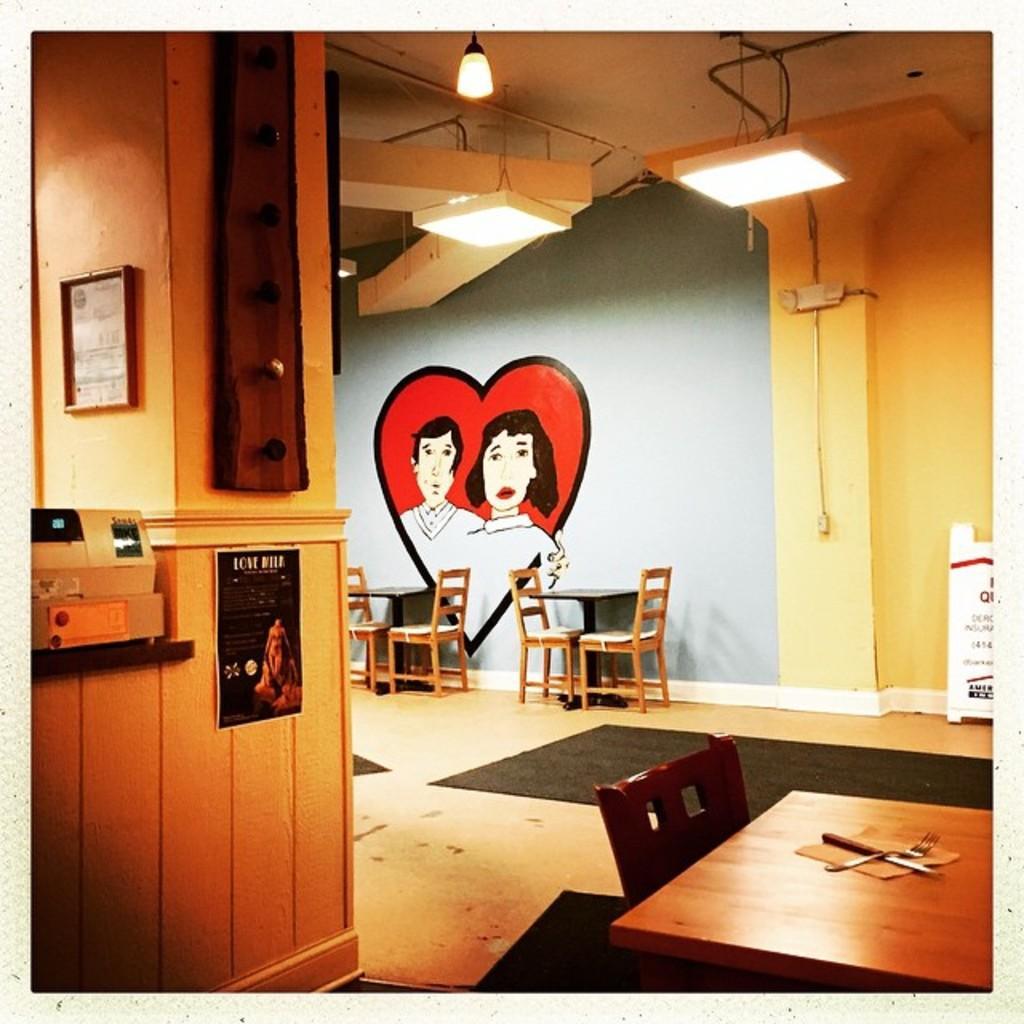Could you give a brief overview of what you see in this image? In this image I can see there are few tables, chairs and there is a knife, fork and a napkin placed on the table, there is a wall in the backdrop and there is a painting on it and there are few lights attached and there is a pillar at left side. 